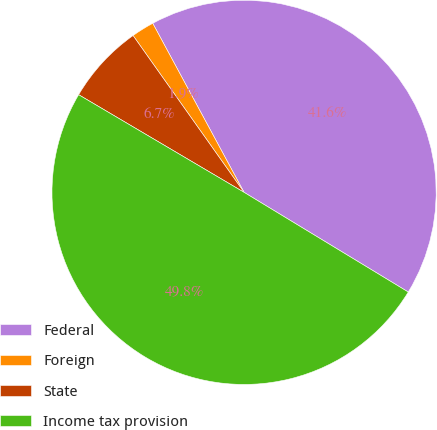Convert chart. <chart><loc_0><loc_0><loc_500><loc_500><pie_chart><fcel>Federal<fcel>Foreign<fcel>State<fcel>Income tax provision<nl><fcel>41.57%<fcel>1.92%<fcel>6.71%<fcel>49.8%<nl></chart> 